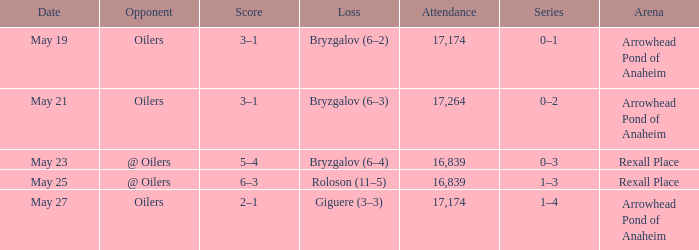Which Attendance has an Opponent of @ oilers, and a Date of may 25? 16839.0. 